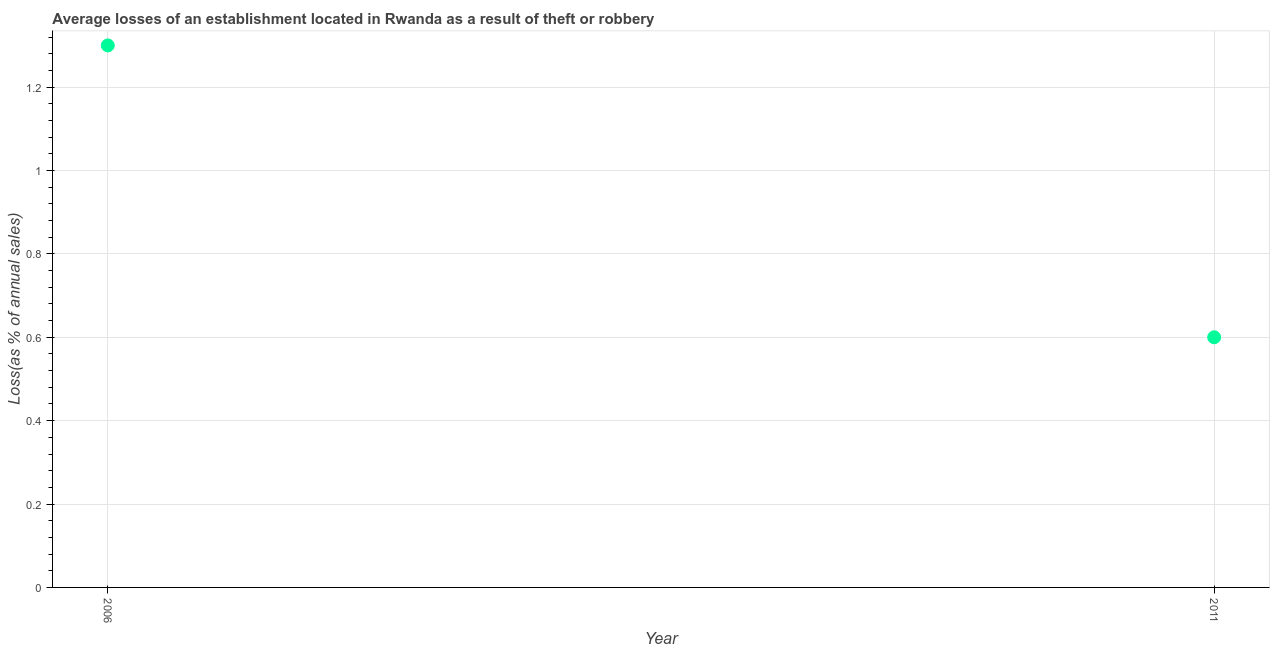Across all years, what is the minimum losses due to theft?
Make the answer very short. 0.6. In which year was the losses due to theft maximum?
Offer a very short reply. 2006. What is the sum of the losses due to theft?
Your answer should be compact. 1.9. What is the difference between the losses due to theft in 2006 and 2011?
Give a very brief answer. 0.7. What is the median losses due to theft?
Your response must be concise. 0.95. In how many years, is the losses due to theft greater than 0.7200000000000001 %?
Your answer should be compact. 1. What is the ratio of the losses due to theft in 2006 to that in 2011?
Offer a very short reply. 2.17. Does the losses due to theft monotonically increase over the years?
Give a very brief answer. No. How many dotlines are there?
Your answer should be compact. 1. Does the graph contain any zero values?
Offer a terse response. No. What is the title of the graph?
Ensure brevity in your answer.  Average losses of an establishment located in Rwanda as a result of theft or robbery. What is the label or title of the Y-axis?
Keep it short and to the point. Loss(as % of annual sales). What is the Loss(as % of annual sales) in 2006?
Make the answer very short. 1.3. What is the ratio of the Loss(as % of annual sales) in 2006 to that in 2011?
Make the answer very short. 2.17. 